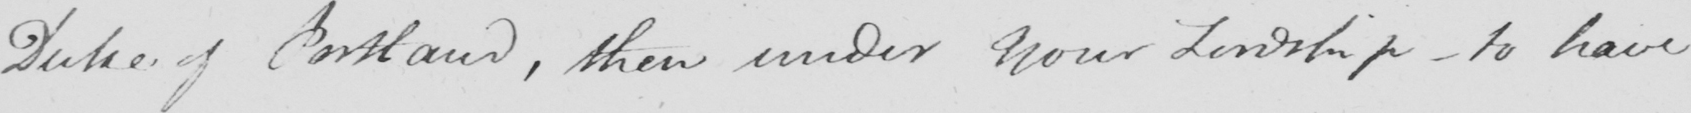Can you tell me what this handwritten text says? Duke of Portland , then under Your Lordship  _  to have 